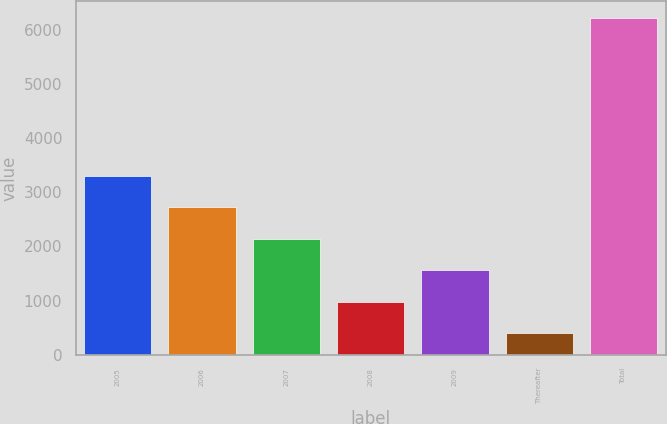<chart> <loc_0><loc_0><loc_500><loc_500><bar_chart><fcel>2005<fcel>2006<fcel>2007<fcel>2008<fcel>2009<fcel>Thereafter<fcel>Total<nl><fcel>3310.5<fcel>2728.4<fcel>2146.3<fcel>982.1<fcel>1564.2<fcel>400<fcel>6221<nl></chart> 